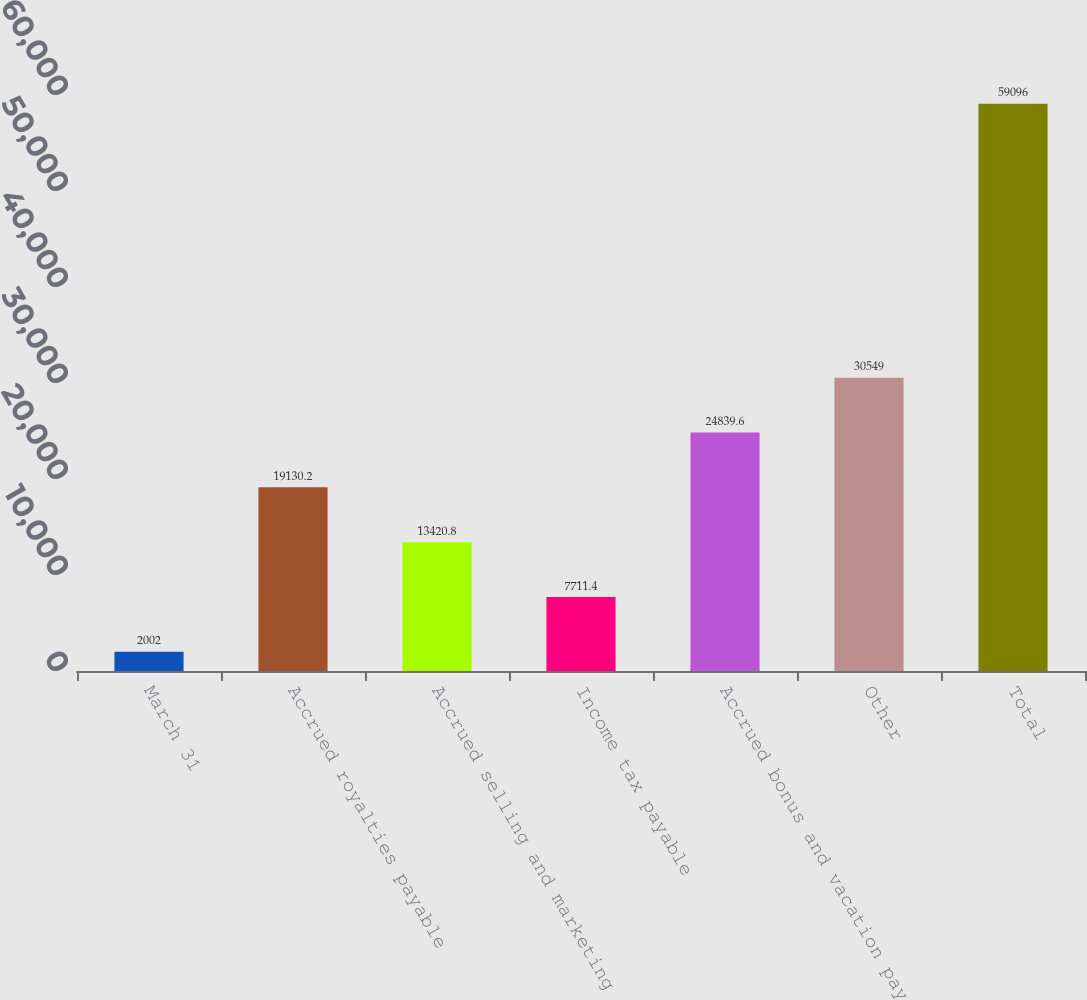Convert chart to OTSL. <chart><loc_0><loc_0><loc_500><loc_500><bar_chart><fcel>March 31<fcel>Accrued royalties payable<fcel>Accrued selling and marketing<fcel>Income tax payable<fcel>Accrued bonus and vacation pay<fcel>Other<fcel>Total<nl><fcel>2002<fcel>19130.2<fcel>13420.8<fcel>7711.4<fcel>24839.6<fcel>30549<fcel>59096<nl></chart> 